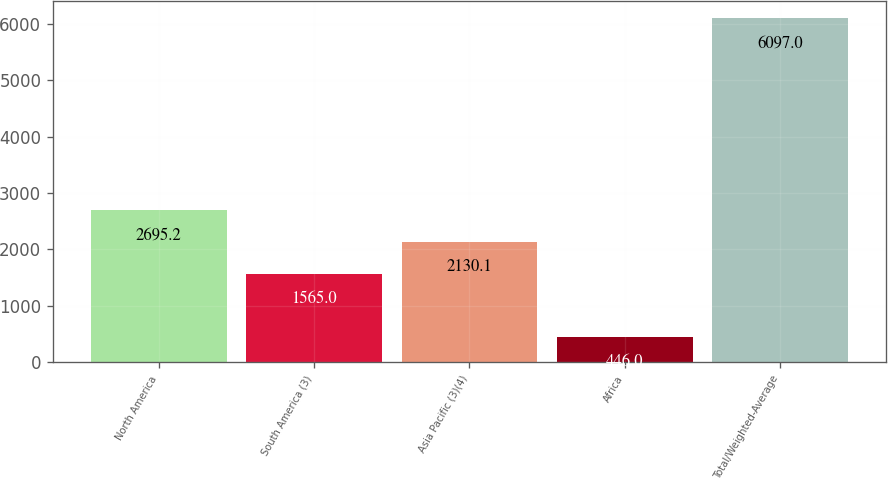Convert chart. <chart><loc_0><loc_0><loc_500><loc_500><bar_chart><fcel>North America<fcel>South America (3)<fcel>Asia Pacific (3)(4)<fcel>Africa<fcel>Total/Weighted-Average<nl><fcel>2695.2<fcel>1565<fcel>2130.1<fcel>446<fcel>6097<nl></chart> 